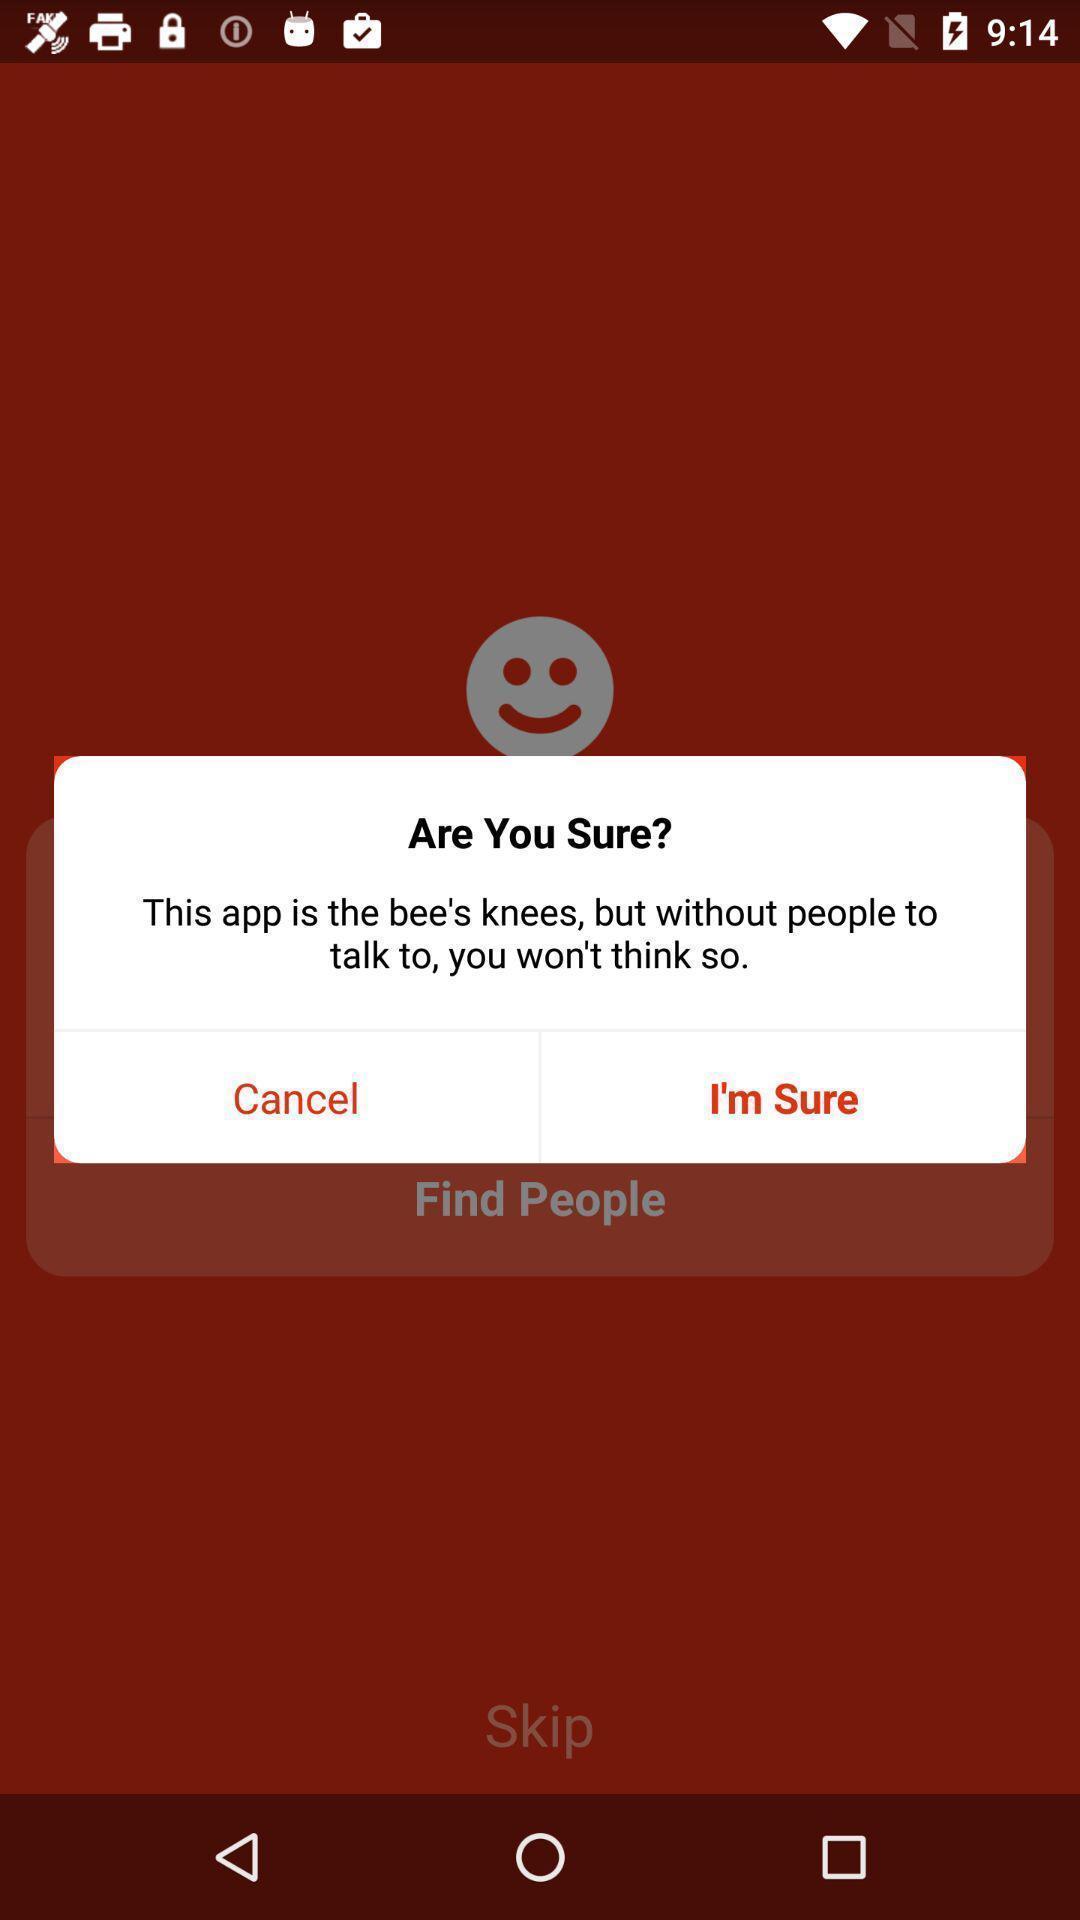Tell me what you see in this picture. Pop-up showing a notification for using this app. 